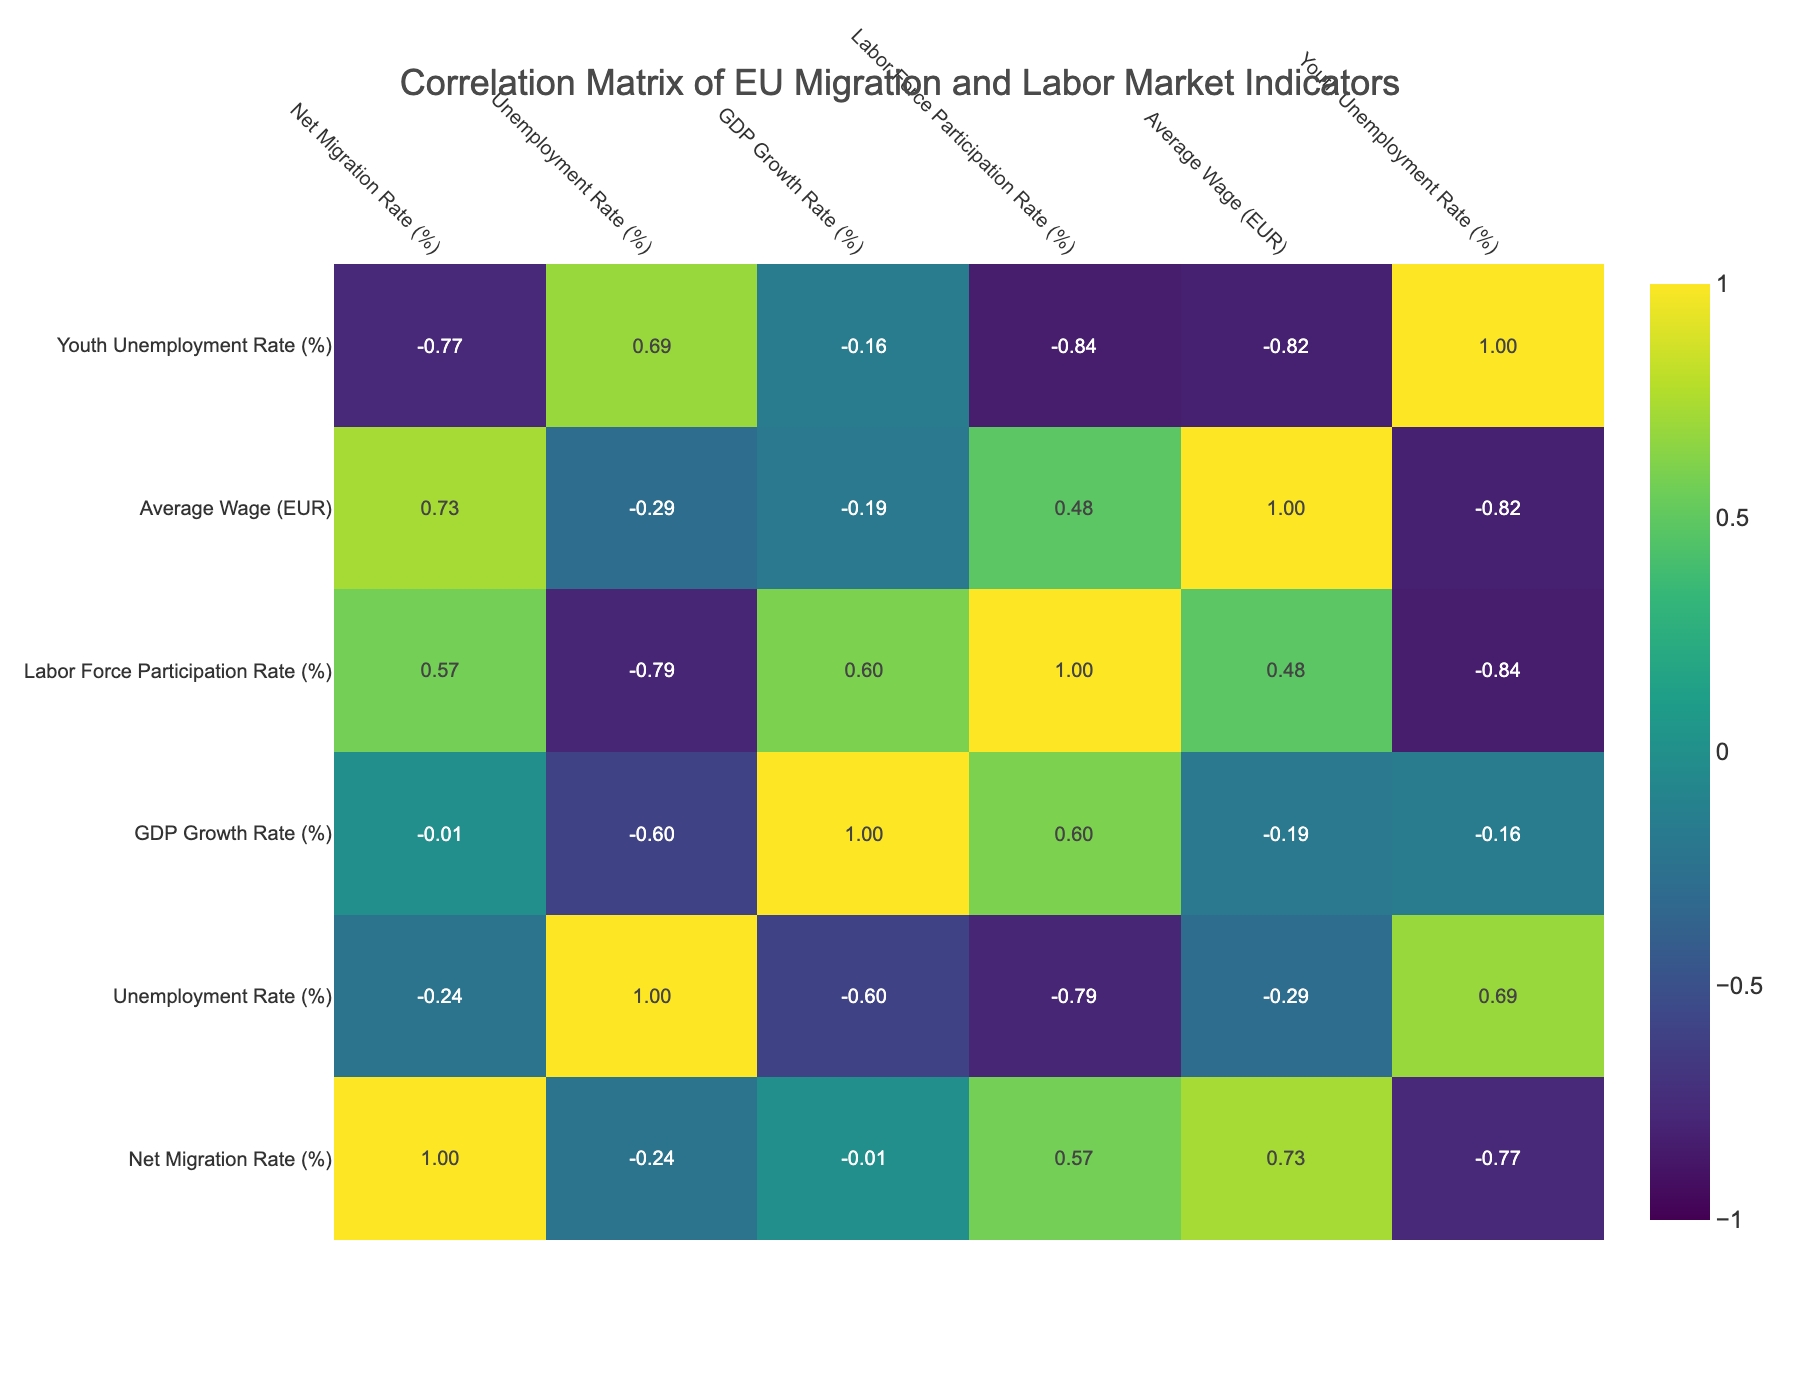What is the net migration rate for Germany? According to the table, the net migration rate for Germany is listed as 2.5%.
Answer: 2.5% Which country has the highest unemployment rate? The table shows that Italy has the highest unemployment rate at 9.5%.
Answer: Italy What is the average wage for Sweden? From the table, the average wage for Sweden is given as 2900 EUR.
Answer: 2900 EUR Is the labor force participation rate in France higher than in Italy? By comparing the labor force participation rates, France has 71%, while Italy has 58%. Since 71% is greater than 58%, the statement is true.
Answer: Yes What is the difference in the average wage between Germany and Portugal? The average wage for Germany is 3000 EUR, and for Portugal, it is 1800 EUR. The difference is calculated as 3000 - 1800 = 1200 EUR.
Answer: 1200 EUR Which country has both a net migration rate and GDP growth rate lower than those of Ireland? The net migration rate and GDP growth rate for Ireland are 2.0% and 3.4% respectively. Poland has a net migration rate of 0.8% and GDP growth rate of 5.5%. However, both values for Portugal (0.4% and 2.2%) are lower than those for Ireland. Thus, Portugal is the answer.
Answer: Portugal What is the average youth unemployment rate across all countries in the table? To calculate the average youth unemployment rate, first sum the youth unemployment rates of each country (6.5 + 15.0 + 29.0 + 32.5 + 8.0 + 23.0 + 12.0 + 25.0 + 9.0 + 10.5 =  170.5), then divide by the number of countries (10): 170.5 / 10 = 17.05%.
Answer: 17.05% Does Sweden have a higher GDP growth rate than France? The GDP growth rate for Sweden is 2.6%, while for France it is 2.5%. Since 2.6% is greater than 2.5%, this statement is true.
Answer: Yes What is the relationship between net migration rate and average wage based on the table? From the table, countries with higher net migration rates such as Germany (2.5%), Netherlands (2.3%), and Sweden (3.1%) generally correspond with higher average wages (3000 EUR, 2800 EUR, and 2900 EUR respectively). This suggests a positive correlation.
Answer: Positive correlation 